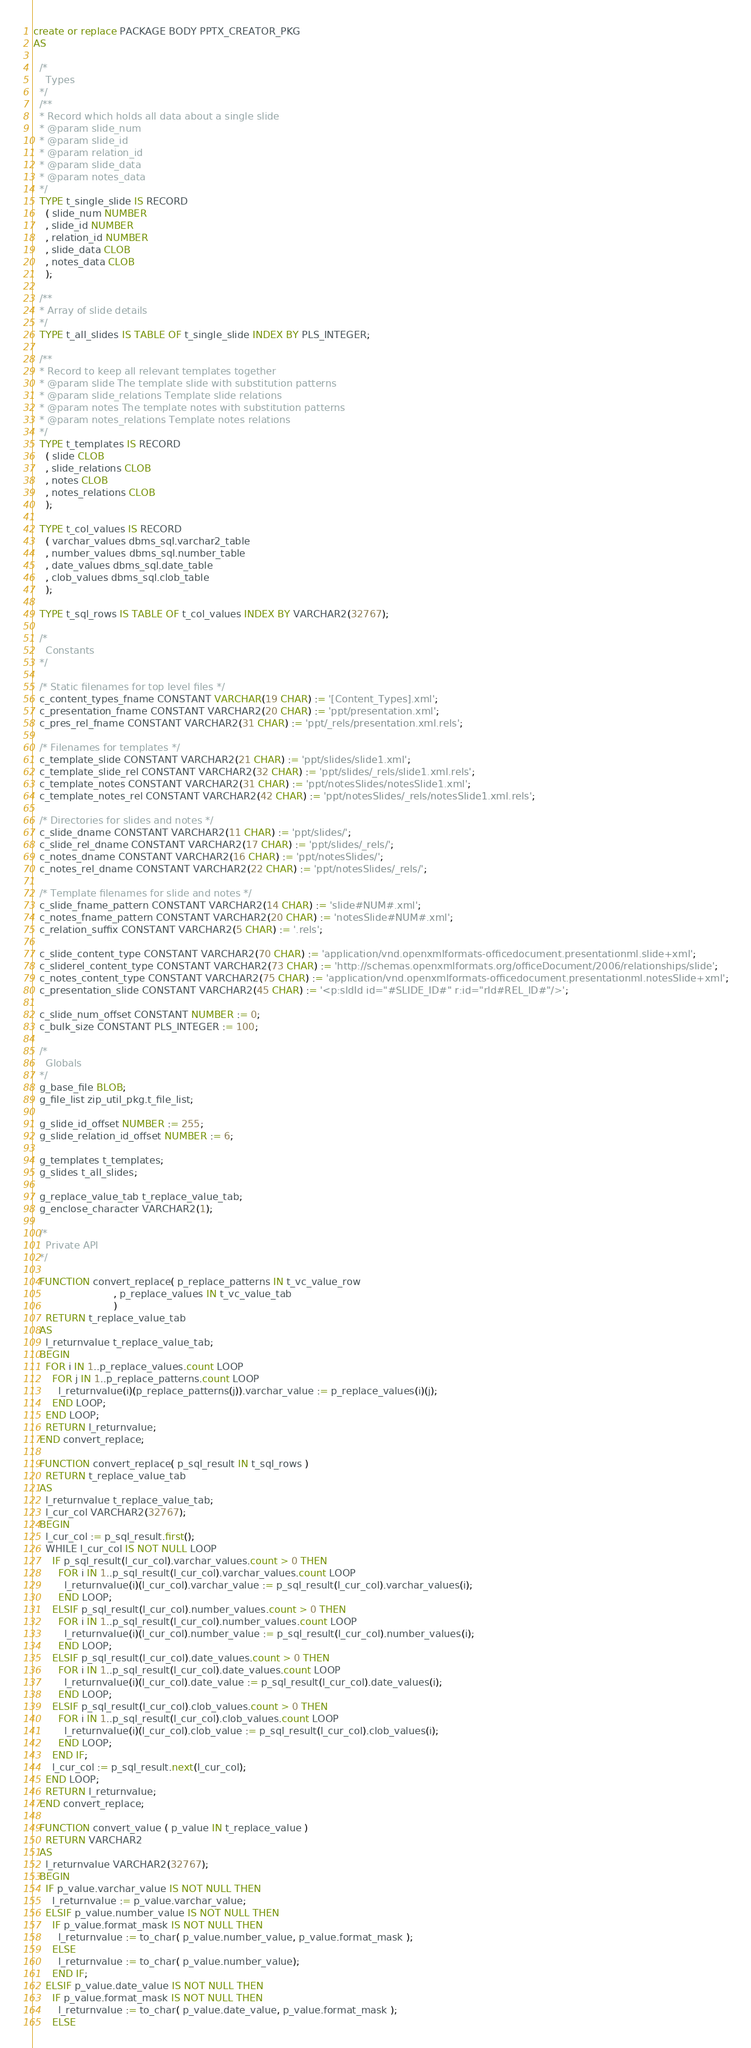<code> <loc_0><loc_0><loc_500><loc_500><_SQL_>create or replace PACKAGE BODY PPTX_CREATOR_PKG
AS

  /*
    Types
  */
  /**
  * Record which holds all data about a single slide
  * @param slide_num
  * @param slide_id
  * @param relation_id
  * @param slide_data
  * @param notes_data
  */
  TYPE t_single_slide IS RECORD
    ( slide_num NUMBER
    , slide_id NUMBER
    , relation_id NUMBER
    , slide_data CLOB
    , notes_data CLOB
    );

  /**
  * Array of slide details
  */
  TYPE t_all_slides IS TABLE OF t_single_slide INDEX BY PLS_INTEGER;

  /**
  * Record to keep all relevant templates together
  * @param slide The template slide with substitution patterns
  * @param slide_relations Template slide relations
  * @param notes The template notes with substitution patterns
  * @param notes_relations Template notes relations
  */
  TYPE t_templates IS RECORD
    ( slide CLOB
    , slide_relations CLOB
    , notes CLOB
    , notes_relations CLOB
    );

  TYPE t_col_values IS RECORD
    ( varchar_values dbms_sql.varchar2_table
    , number_values dbms_sql.number_table
    , date_values dbms_sql.date_table
    , clob_values dbms_sql.clob_table
    );
    
  TYPE t_sql_rows IS TABLE OF t_col_values INDEX BY VARCHAR2(32767);

  /*
    Constants
  */
  
  /* Static filenames for top level files */
  c_content_types_fname CONSTANT VARCHAR(19 CHAR) := '[Content_Types].xml';
  c_presentation_fname CONSTANT VARCHAR2(20 CHAR) := 'ppt/presentation.xml';
  c_pres_rel_fname CONSTANT VARCHAR2(31 CHAR) := 'ppt/_rels/presentation.xml.rels';
  
  /* Filenames for templates */
  c_template_slide CONSTANT VARCHAR2(21 CHAR) := 'ppt/slides/slide1.xml';
  c_template_slide_rel CONSTANT VARCHAR2(32 CHAR) := 'ppt/slides/_rels/slide1.xml.rels';
  c_template_notes CONSTANT VARCHAR2(31 CHAR) := 'ppt/notesSlides/notesSlide1.xml';
  c_template_notes_rel CONSTANT VARCHAR2(42 CHAR) := 'ppt/notesSlides/_rels/notesSlide1.xml.rels';
  
  /* Directories for slides and notes */
  c_slide_dname CONSTANT VARCHAR2(11 CHAR) := 'ppt/slides/';
  c_slide_rel_dname CONSTANT VARCHAR2(17 CHAR) := 'ppt/slides/_rels/';
  c_notes_dname CONSTANT VARCHAR2(16 CHAR) := 'ppt/notesSlides/';
  c_notes_rel_dname CONSTANT VARCHAR2(22 CHAR) := 'ppt/notesSlides/_rels/';
  
  /* Template filenames for slide and notes */
  c_slide_fname_pattern CONSTANT VARCHAR2(14 CHAR) := 'slide#NUM#.xml';
  c_notes_fname_pattern CONSTANT VARCHAR2(20 CHAR) := 'notesSlide#NUM#.xml';
  c_relation_suffix CONSTANT VARCHAR2(5 CHAR) := '.rels';

  c_slide_content_type CONSTANT VARCHAR2(70 CHAR) := 'application/vnd.openxmlformats-officedocument.presentationml.slide+xml';
  c_sliderel_content_type CONSTANT VARCHAR2(73 CHAR) := 'http://schemas.openxmlformats.org/officeDocument/2006/relationships/slide';
  c_notes_content_type CONSTANT VARCHAR2(75 CHAR) := 'application/vnd.openxmlformats-officedocument.presentationml.notesSlide+xml';
  c_presentation_slide CONSTANT VARCHAR2(45 CHAR) := '<p:sldId id="#SLIDE_ID#" r:id="rId#REL_ID#"/>';

  c_slide_num_offset CONSTANT NUMBER := 0;
  c_bulk_size CONSTANT PLS_INTEGER := 100;

  /*
    Globals
  */
  g_base_file BLOB;
  g_file_list zip_util_pkg.t_file_list;

  g_slide_id_offset NUMBER := 255;
  g_slide_relation_id_offset NUMBER := 6;

  g_templates t_templates;
  g_slides t_all_slides;

  g_replace_value_tab t_replace_value_tab;
  g_enclose_character VARCHAR2(1);

  /*
    Private API
  */

  FUNCTION convert_replace( p_replace_patterns IN t_vc_value_row
                          , p_replace_values IN t_vc_value_tab
                          )
    RETURN t_replace_value_tab
  AS
    l_returnvalue t_replace_value_tab;
  BEGIN
    FOR i IN 1..p_replace_values.count LOOP
      FOR j IN 1..p_replace_patterns.count LOOP
        l_returnvalue(i)(p_replace_patterns(j)).varchar_value := p_replace_values(i)(j);
      END LOOP;
    END LOOP;
    RETURN l_returnvalue;
  END convert_replace;
  
  FUNCTION convert_replace( p_sql_result IN t_sql_rows )
    RETURN t_replace_value_tab
  AS
    l_returnvalue t_replace_value_tab;
    l_cur_col VARCHAR2(32767);
  BEGIN
    l_cur_col := p_sql_result.first();
    WHILE l_cur_col IS NOT NULL LOOP
      IF p_sql_result(l_cur_col).varchar_values.count > 0 THEN
        FOR i IN 1..p_sql_result(l_cur_col).varchar_values.count LOOP
          l_returnvalue(i)(l_cur_col).varchar_value := p_sql_result(l_cur_col).varchar_values(i);
        END LOOP;
      ELSIF p_sql_result(l_cur_col).number_values.count > 0 THEN
        FOR i IN 1..p_sql_result(l_cur_col).number_values.count LOOP
          l_returnvalue(i)(l_cur_col).number_value := p_sql_result(l_cur_col).number_values(i);
        END LOOP;
      ELSIF p_sql_result(l_cur_col).date_values.count > 0 THEN
        FOR i IN 1..p_sql_result(l_cur_col).date_values.count LOOP
          l_returnvalue(i)(l_cur_col).date_value := p_sql_result(l_cur_col).date_values(i);
        END LOOP;
      ELSIF p_sql_result(l_cur_col).clob_values.count > 0 THEN
        FOR i IN 1..p_sql_result(l_cur_col).clob_values.count LOOP
          l_returnvalue(i)(l_cur_col).clob_value := p_sql_result(l_cur_col).clob_values(i);
        END LOOP;      
      END IF;
      l_cur_col := p_sql_result.next(l_cur_col);
    END LOOP;
    RETURN l_returnvalue;
  END convert_replace;

  FUNCTION convert_value ( p_value IN t_replace_value )
    RETURN VARCHAR2
  AS
    l_returnvalue VARCHAR2(32767);
  BEGIN
    IF p_value.varchar_value IS NOT NULL THEN
      l_returnvalue := p_value.varchar_value;
    ELSIF p_value.number_value IS NOT NULL THEN
      IF p_value.format_mask IS NOT NULL THEN
        l_returnvalue := to_char( p_value.number_value, p_value.format_mask );
      ELSE
        l_returnvalue := to_char( p_value.number_value);
      END IF;
    ELSIF p_value.date_value IS NOT NULL THEN
      IF p_value.format_mask IS NOT NULL THEN
        l_returnvalue := to_char( p_value.date_value, p_value.format_mask );
      ELSE</code> 